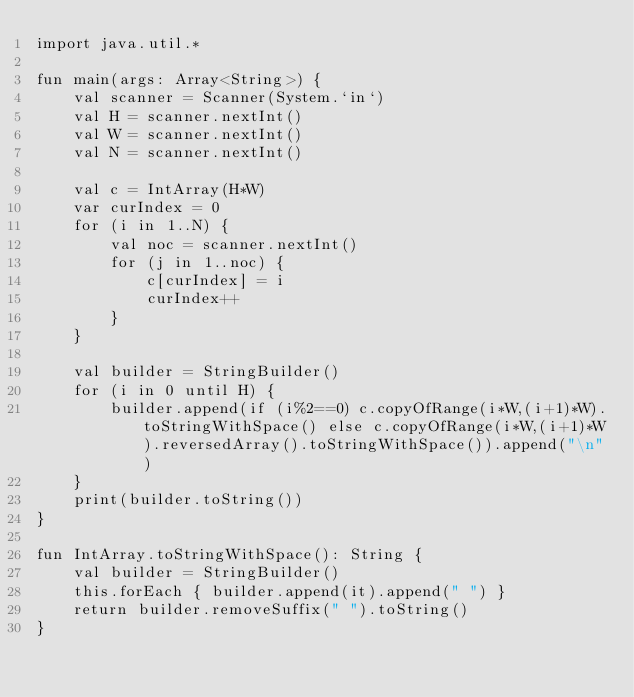Convert code to text. <code><loc_0><loc_0><loc_500><loc_500><_Kotlin_>import java.util.*

fun main(args: Array<String>) {
    val scanner = Scanner(System.`in`)
    val H = scanner.nextInt()
    val W = scanner.nextInt()
    val N = scanner.nextInt()

    val c = IntArray(H*W)
    var curIndex = 0
    for (i in 1..N) {
        val noc = scanner.nextInt()
        for (j in 1..noc) {
            c[curIndex] = i
            curIndex++
        }
    }

    val builder = StringBuilder()
    for (i in 0 until H) {
        builder.append(if (i%2==0) c.copyOfRange(i*W,(i+1)*W).toStringWithSpace() else c.copyOfRange(i*W,(i+1)*W).reversedArray().toStringWithSpace()).append("\n")
    }
    print(builder.toString())
}

fun IntArray.toStringWithSpace(): String {
    val builder = StringBuilder()
    this.forEach { builder.append(it).append(" ") }
    return builder.removeSuffix(" ").toString()
}</code> 